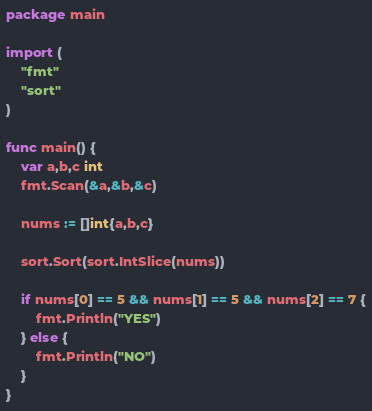Convert code to text. <code><loc_0><loc_0><loc_500><loc_500><_Go_>package main

import (
	"fmt"
	"sort"
)

func main() {
	var a,b,c int
	fmt.Scan(&a,&b,&c)
	
	nums := []int{a,b,c}
	
	sort.Sort(sort.IntSlice(nums))
	
	if nums[0] == 5 && nums[1] == 5 && nums[2] == 7 {
		fmt.Println("YES")
	} else {
		fmt.Println("NO")
	}
}</code> 